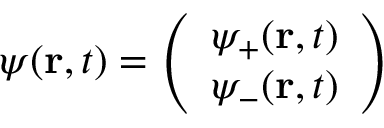Convert formula to latex. <formula><loc_0><loc_0><loc_500><loc_500>\psi ( r , t ) = { \left ( \begin{array} { l } { \psi _ { + } ( r , t ) } \\ { \psi _ { - } ( r , t ) } \end{array} \right ) }</formula> 